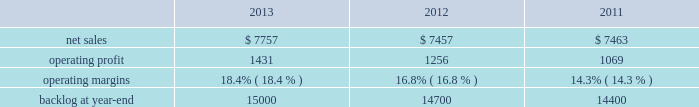Warfighter information network-tactical ( win-t ) ; command , control , battle management and communications ( c2bmc ) ; and twic ) .
Partially offsetting the decreases were higher net sales of approximately $ 140 million from qtc , which was acquired early in the fourth quarter of 2011 ; and about $ 65 million from increased activity on numerous other programs , primarily federal cyber security programs and ptds operational support .
Is&gs 2019 operating profit for 2012 decreased $ 66 million , or 8% ( 8 % ) , compared to 2011 .
The decrease was attributable to lower operating profit of approximately $ 50 million due to the favorable impact of the odin contract completion in 2011 ; about $ 25 million due to an increase in reserves for performance issues related to an international airborne surveillance system in 2012 ; and approximately $ 20 million due to lower volume on certain programs ( primarily c2bmc and win-t ) .
Partially offsetting the decreases was an increase in operating profit due to higher risk retirements of approximately $ 15 million from the twic program ; and about $ 10 million due to increased activity on numerous other programs , primarily federal cyber security programs and ptds operational support .
Operating profit for the jtrs program was comparable as a decrease in volume was offset by a decrease in reserves .
Adjustments not related to volume , including net profit booking rate adjustments and other matters described above , were approximately $ 20 million higher for 2012 compared to 2011 .
Backlog backlog decreased in 2013 compared to 2012 primarily due to lower orders on several programs ( such as eram and ngi ) , higher sales on certain programs ( the national science foundation antarctic support and the disa gsm-o ) , and declining activities on several smaller programs primarily due to the continued downturn in federal information technology budgets .
Backlog decreased in 2012 compared to 2011 primarily due to the substantial completion of various programs in 2011 ( primarily odin , u.k .
Census , and jtrs ) .
Trends we expect is&gs 2019 net sales to decline in 2014 in the high single digit percentage range as compared to 2013 primarily due to the continued downturn in federal information technology budgets .
Operating profit is also expected to decline in 2014 in the high single digit percentage range consistent with the expected decline in net sales , resulting in margins that are comparable with 2013 results .
Missiles and fire control our mfc business segment provides air and missile defense systems ; tactical missiles and air-to-ground precision strike weapon systems ; logistics and other technical services ; fire control systems ; mission operations support , readiness , engineering support , and integration services ; and manned and unmanned ground vehicles .
Mfc 2019s major programs include pac-3 , thaad , multiple launch rocket system , hellfire , joint air-to-surface standoff missile ( jassm ) , javelin , apache fire control system ( apache ) , sniper ae , low altitude navigation and targeting infrared for night ( lantirn ae ) , and sof clss .
Mfc 2019s operating results included the following ( in millions ) : .
2013 compared to 2012 mfc 2019s net sales for 2013 increased $ 300 million , or 4% ( 4 % ) , compared to 2012 .
The increase was primarily attributable to higher net sales of approximately $ 450 million for air and missile defense programs ( thaad and pac-3 ) due to increased production volume and deliveries ; about $ 70 million for fire control programs due to net increased deliveries and volume ; and approximately $ 55 million for tactical missile programs due to net increased deliveries .
The increases were partially offset by lower net sales of about $ 275 million for various technical services programs due to lower volume driven by the continuing impact of defense budget reductions and related competitive pressures .
The increase for fire control programs was primarily attributable to increased deliveries on the sniper ae and lantirn ae programs , increased volume on the sof clss program , partially offset by lower volume on longbow fire control radar and other programs .
The increase for tactical missile programs was primarily attributable to increased deliveries on jassm and other programs , partially offset by fewer deliveries on the guided multiple launch rocket system and javelin programs. .
What was average operating margins for mfc from 2011 to 2013? 
Computations: table_average(operating margins, none)
Answer: 0.165. 